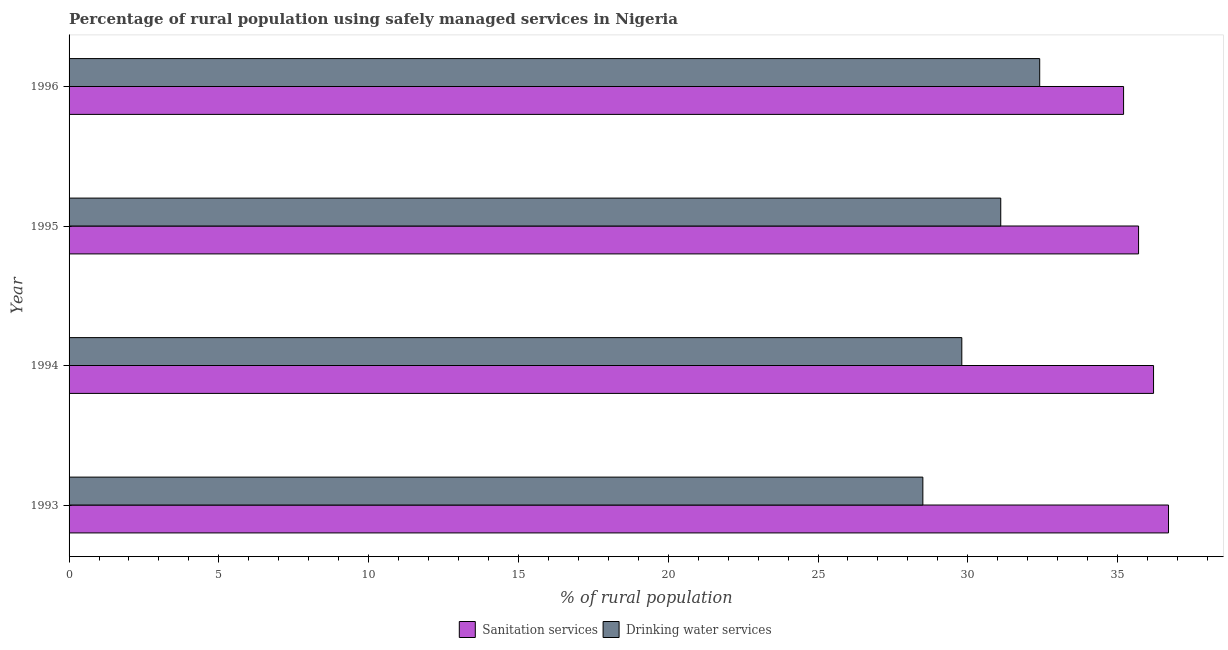How many different coloured bars are there?
Your answer should be very brief. 2. Are the number of bars per tick equal to the number of legend labels?
Offer a terse response. Yes. How many bars are there on the 4th tick from the bottom?
Offer a very short reply. 2. What is the label of the 3rd group of bars from the top?
Offer a very short reply. 1994. In how many cases, is the number of bars for a given year not equal to the number of legend labels?
Keep it short and to the point. 0. What is the percentage of rural population who used sanitation services in 1993?
Offer a very short reply. 36.7. Across all years, what is the maximum percentage of rural population who used drinking water services?
Your answer should be compact. 32.4. Across all years, what is the minimum percentage of rural population who used sanitation services?
Give a very brief answer. 35.2. In which year was the percentage of rural population who used sanitation services minimum?
Offer a terse response. 1996. What is the total percentage of rural population who used drinking water services in the graph?
Your answer should be compact. 121.8. What is the difference between the percentage of rural population who used drinking water services in 1993 and the percentage of rural population who used sanitation services in 1996?
Your answer should be very brief. -6.7. What is the average percentage of rural population who used drinking water services per year?
Make the answer very short. 30.45. In the year 1994, what is the difference between the percentage of rural population who used sanitation services and percentage of rural population who used drinking water services?
Your answer should be compact. 6.4. What is the ratio of the percentage of rural population who used sanitation services in 1994 to that in 1995?
Keep it short and to the point. 1.01. Is the difference between the percentage of rural population who used sanitation services in 1995 and 1996 greater than the difference between the percentage of rural population who used drinking water services in 1995 and 1996?
Your answer should be compact. Yes. What is the difference between the highest and the lowest percentage of rural population who used drinking water services?
Provide a short and direct response. 3.9. Is the sum of the percentage of rural population who used sanitation services in 1993 and 1994 greater than the maximum percentage of rural population who used drinking water services across all years?
Offer a terse response. Yes. What does the 2nd bar from the top in 1995 represents?
Keep it short and to the point. Sanitation services. What does the 1st bar from the bottom in 1994 represents?
Ensure brevity in your answer.  Sanitation services. What is the difference between two consecutive major ticks on the X-axis?
Your response must be concise. 5. Are the values on the major ticks of X-axis written in scientific E-notation?
Provide a succinct answer. No. Does the graph contain any zero values?
Your answer should be very brief. No. Where does the legend appear in the graph?
Provide a succinct answer. Bottom center. What is the title of the graph?
Make the answer very short. Percentage of rural population using safely managed services in Nigeria. Does "From production" appear as one of the legend labels in the graph?
Give a very brief answer. No. What is the label or title of the X-axis?
Offer a terse response. % of rural population. What is the label or title of the Y-axis?
Make the answer very short. Year. What is the % of rural population in Sanitation services in 1993?
Provide a short and direct response. 36.7. What is the % of rural population in Drinking water services in 1993?
Give a very brief answer. 28.5. What is the % of rural population in Sanitation services in 1994?
Offer a very short reply. 36.2. What is the % of rural population of Drinking water services in 1994?
Your answer should be very brief. 29.8. What is the % of rural population in Sanitation services in 1995?
Provide a succinct answer. 35.7. What is the % of rural population of Drinking water services in 1995?
Offer a terse response. 31.1. What is the % of rural population in Sanitation services in 1996?
Keep it short and to the point. 35.2. What is the % of rural population of Drinking water services in 1996?
Your answer should be compact. 32.4. Across all years, what is the maximum % of rural population in Sanitation services?
Offer a terse response. 36.7. Across all years, what is the maximum % of rural population in Drinking water services?
Give a very brief answer. 32.4. Across all years, what is the minimum % of rural population of Sanitation services?
Provide a succinct answer. 35.2. Across all years, what is the minimum % of rural population in Drinking water services?
Ensure brevity in your answer.  28.5. What is the total % of rural population in Sanitation services in the graph?
Make the answer very short. 143.8. What is the total % of rural population in Drinking water services in the graph?
Your response must be concise. 121.8. What is the difference between the % of rural population of Sanitation services in 1993 and that in 1994?
Provide a short and direct response. 0.5. What is the difference between the % of rural population of Drinking water services in 1993 and that in 1994?
Offer a terse response. -1.3. What is the difference between the % of rural population in Sanitation services in 1994 and that in 1995?
Give a very brief answer. 0.5. What is the difference between the % of rural population of Drinking water services in 1994 and that in 1995?
Offer a terse response. -1.3. What is the difference between the % of rural population in Sanitation services in 1995 and that in 1996?
Your response must be concise. 0.5. What is the difference between the % of rural population of Drinking water services in 1995 and that in 1996?
Offer a terse response. -1.3. What is the difference between the % of rural population in Sanitation services in 1993 and the % of rural population in Drinking water services in 1996?
Give a very brief answer. 4.3. What is the difference between the % of rural population of Sanitation services in 1994 and the % of rural population of Drinking water services in 1996?
Your answer should be compact. 3.8. What is the difference between the % of rural population in Sanitation services in 1995 and the % of rural population in Drinking water services in 1996?
Make the answer very short. 3.3. What is the average % of rural population in Sanitation services per year?
Offer a terse response. 35.95. What is the average % of rural population of Drinking water services per year?
Give a very brief answer. 30.45. What is the ratio of the % of rural population in Sanitation services in 1993 to that in 1994?
Provide a succinct answer. 1.01. What is the ratio of the % of rural population in Drinking water services in 1993 to that in 1994?
Provide a short and direct response. 0.96. What is the ratio of the % of rural population of Sanitation services in 1993 to that in 1995?
Provide a short and direct response. 1.03. What is the ratio of the % of rural population of Drinking water services in 1993 to that in 1995?
Make the answer very short. 0.92. What is the ratio of the % of rural population of Sanitation services in 1993 to that in 1996?
Offer a very short reply. 1.04. What is the ratio of the % of rural population in Drinking water services in 1993 to that in 1996?
Provide a succinct answer. 0.88. What is the ratio of the % of rural population of Drinking water services in 1994 to that in 1995?
Ensure brevity in your answer.  0.96. What is the ratio of the % of rural population in Sanitation services in 1994 to that in 1996?
Provide a succinct answer. 1.03. What is the ratio of the % of rural population in Drinking water services in 1994 to that in 1996?
Your response must be concise. 0.92. What is the ratio of the % of rural population in Sanitation services in 1995 to that in 1996?
Your answer should be compact. 1.01. What is the ratio of the % of rural population in Drinking water services in 1995 to that in 1996?
Your response must be concise. 0.96. What is the difference between the highest and the lowest % of rural population in Sanitation services?
Your answer should be very brief. 1.5. What is the difference between the highest and the lowest % of rural population in Drinking water services?
Your answer should be compact. 3.9. 